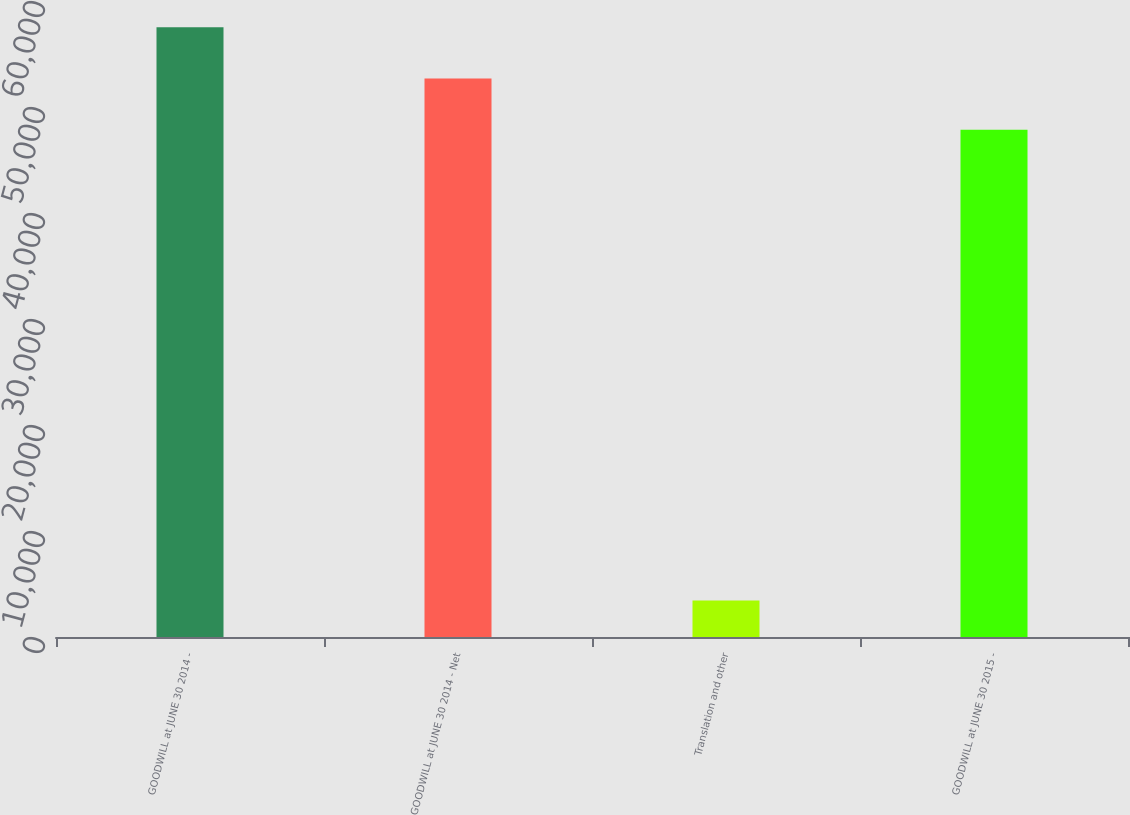Convert chart to OTSL. <chart><loc_0><loc_0><loc_500><loc_500><bar_chart><fcel>GOODWILL at JUNE 30 2014 -<fcel>GOODWILL at JUNE 30 2014 - Net<fcel>Translation and other<fcel>GOODWILL at JUNE 30 2015 -<nl><fcel>57531.6<fcel>52687.8<fcel>3449<fcel>47844<nl></chart> 